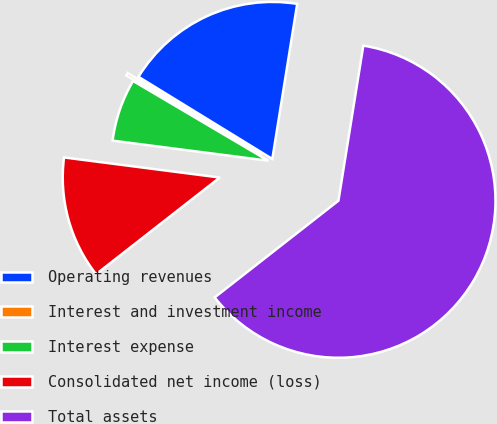<chart> <loc_0><loc_0><loc_500><loc_500><pie_chart><fcel>Operating revenues<fcel>Interest and investment income<fcel>Interest expense<fcel>Consolidated net income (loss)<fcel>Total assets<nl><fcel>18.77%<fcel>0.28%<fcel>6.44%<fcel>12.6%<fcel>61.91%<nl></chart> 